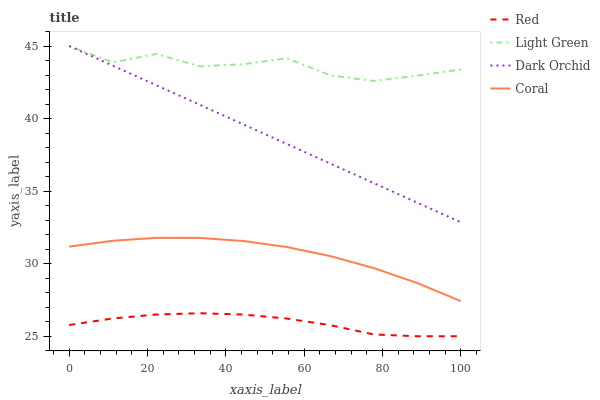Does Coral have the minimum area under the curve?
Answer yes or no. No. Does Coral have the maximum area under the curve?
Answer yes or no. No. Is Coral the smoothest?
Answer yes or no. No. Is Coral the roughest?
Answer yes or no. No. Does Coral have the lowest value?
Answer yes or no. No. Does Coral have the highest value?
Answer yes or no. No. Is Red less than Coral?
Answer yes or no. Yes. Is Light Green greater than Coral?
Answer yes or no. Yes. Does Red intersect Coral?
Answer yes or no. No. 